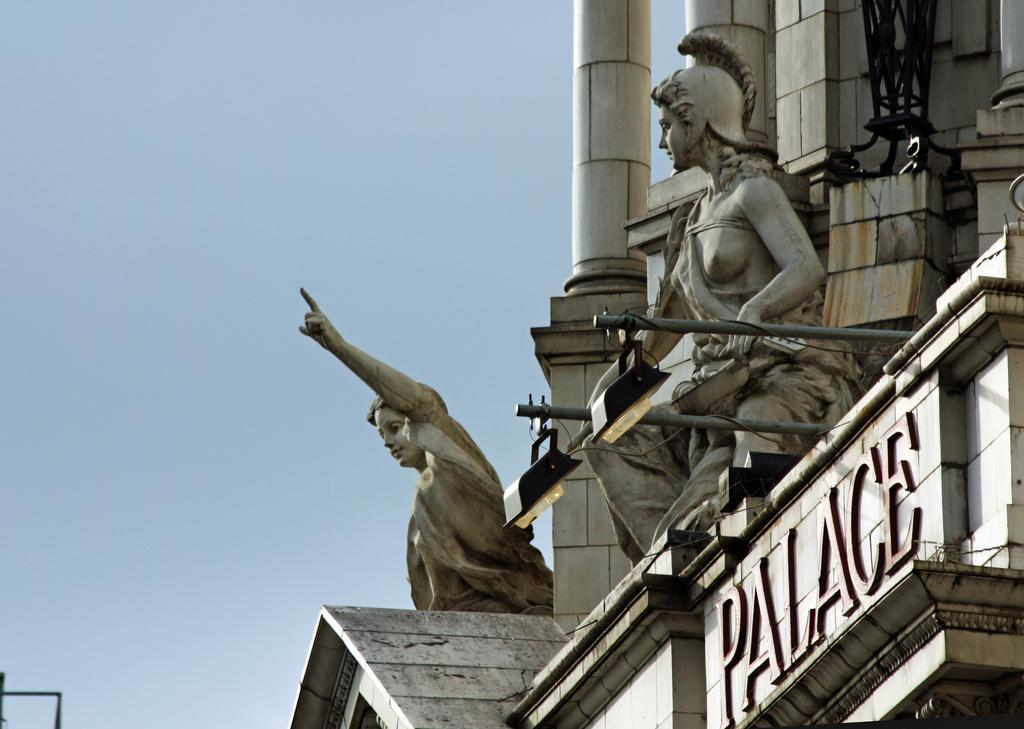What type of structure is present in the image? There is a building in the image. What decorative elements can be seen on the building? The building has sculptures. Is there any signage on the building? Yes, there is a name board on the building. What type of lighting is present in the image? There are lights on poles in the image. What can be seen in the background of the image? The sky is visible in the background of the image. What time is displayed on the clock in the image? There is no clock present in the image. 